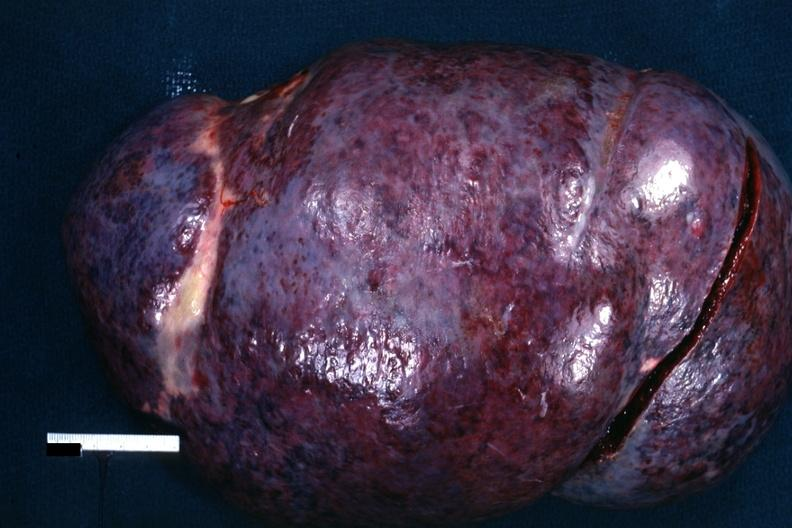how does this image show external view of massively enlarged spleen?
Answer the question using a single word or phrase. With purple color 